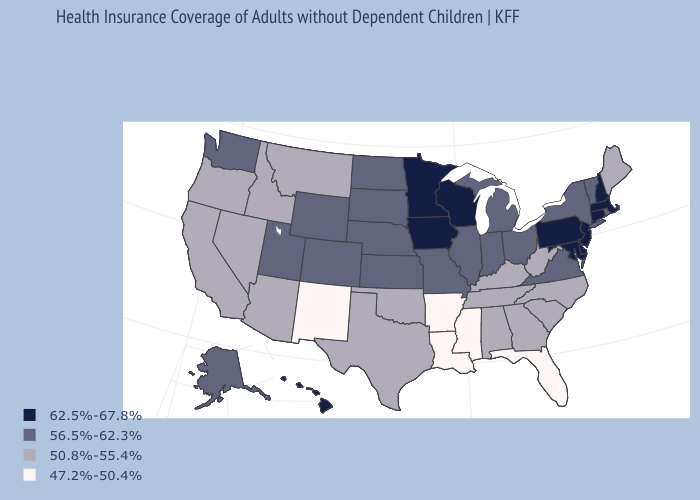Which states have the lowest value in the USA?
Concise answer only. Arkansas, Florida, Louisiana, Mississippi, New Mexico. Name the states that have a value in the range 50.8%-55.4%?
Concise answer only. Alabama, Arizona, California, Georgia, Idaho, Kentucky, Maine, Montana, Nevada, North Carolina, Oklahoma, Oregon, South Carolina, Tennessee, Texas, West Virginia. What is the value of Maine?
Short answer required. 50.8%-55.4%. Does the first symbol in the legend represent the smallest category?
Keep it brief. No. Is the legend a continuous bar?
Short answer required. No. Name the states that have a value in the range 56.5%-62.3%?
Keep it brief. Alaska, Colorado, Illinois, Indiana, Kansas, Michigan, Missouri, Nebraska, New York, North Dakota, Ohio, Rhode Island, South Dakota, Utah, Vermont, Virginia, Washington, Wyoming. What is the lowest value in the USA?
Short answer required. 47.2%-50.4%. Name the states that have a value in the range 50.8%-55.4%?
Answer briefly. Alabama, Arizona, California, Georgia, Idaho, Kentucky, Maine, Montana, Nevada, North Carolina, Oklahoma, Oregon, South Carolina, Tennessee, Texas, West Virginia. What is the value of Wisconsin?
Short answer required. 62.5%-67.8%. Does Hawaii have the highest value in the West?
Answer briefly. Yes. Among the states that border Missouri , does Iowa have the highest value?
Give a very brief answer. Yes. Which states have the lowest value in the MidWest?
Write a very short answer. Illinois, Indiana, Kansas, Michigan, Missouri, Nebraska, North Dakota, Ohio, South Dakota. Name the states that have a value in the range 50.8%-55.4%?
Keep it brief. Alabama, Arizona, California, Georgia, Idaho, Kentucky, Maine, Montana, Nevada, North Carolina, Oklahoma, Oregon, South Carolina, Tennessee, Texas, West Virginia. What is the highest value in the Northeast ?
Keep it brief. 62.5%-67.8%. Does Illinois have a lower value than Massachusetts?
Be succinct. Yes. 